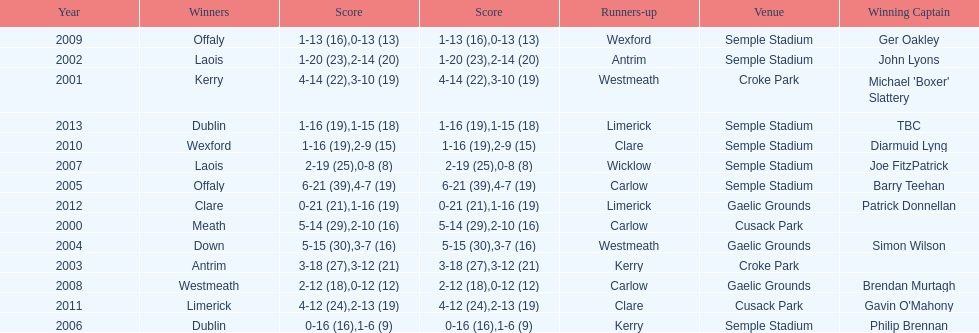What is the difference in the scores in 2000? 13. 